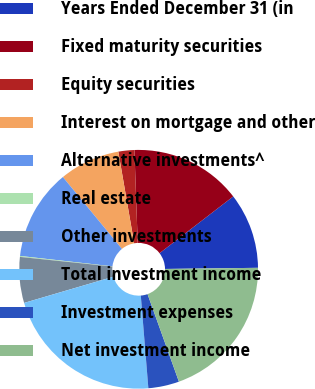Convert chart. <chart><loc_0><loc_0><loc_500><loc_500><pie_chart><fcel>Years Ended December 31 (in<fcel>Fixed maturity securities<fcel>Equity securities<fcel>Interest on mortgage and other<fcel>Alternative investments^<fcel>Real estate<fcel>Other investments<fcel>Total investment income<fcel>Investment expenses<fcel>Net investment income<nl><fcel>10.25%<fcel>15.12%<fcel>2.16%<fcel>8.22%<fcel>12.27%<fcel>0.13%<fcel>6.2%<fcel>21.75%<fcel>4.18%<fcel>19.72%<nl></chart> 